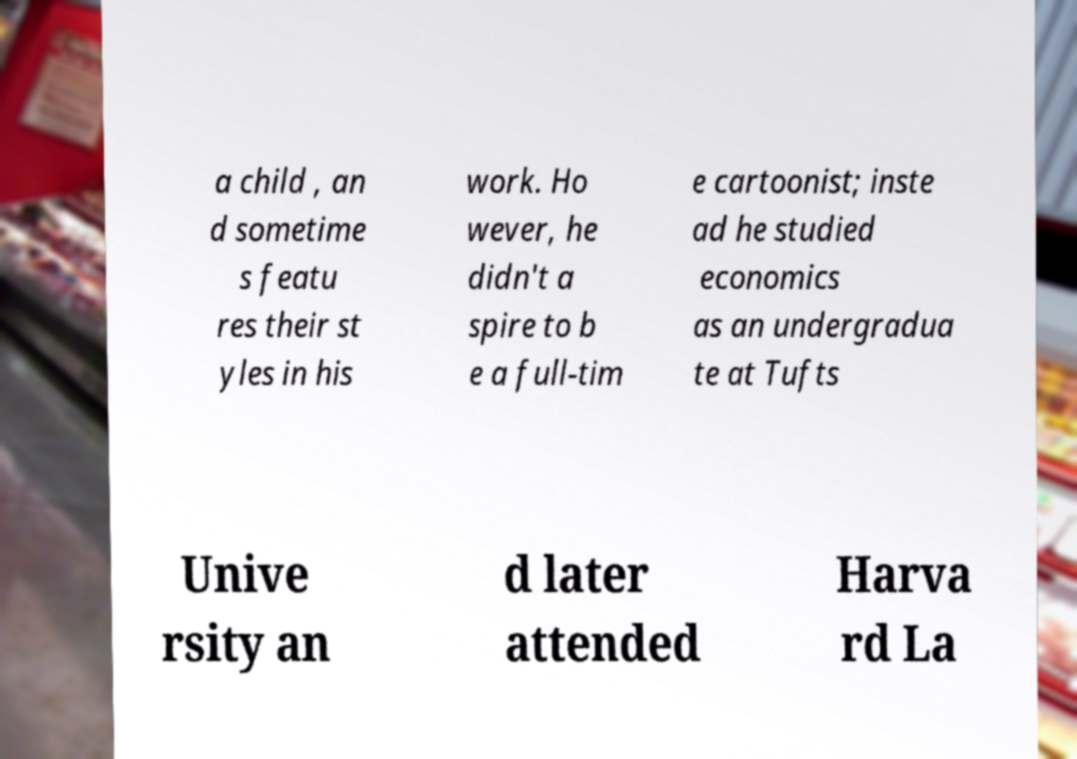For documentation purposes, I need the text within this image transcribed. Could you provide that? a child , an d sometime s featu res their st yles in his work. Ho wever, he didn't a spire to b e a full-tim e cartoonist; inste ad he studied economics as an undergradua te at Tufts Unive rsity an d later attended Harva rd La 